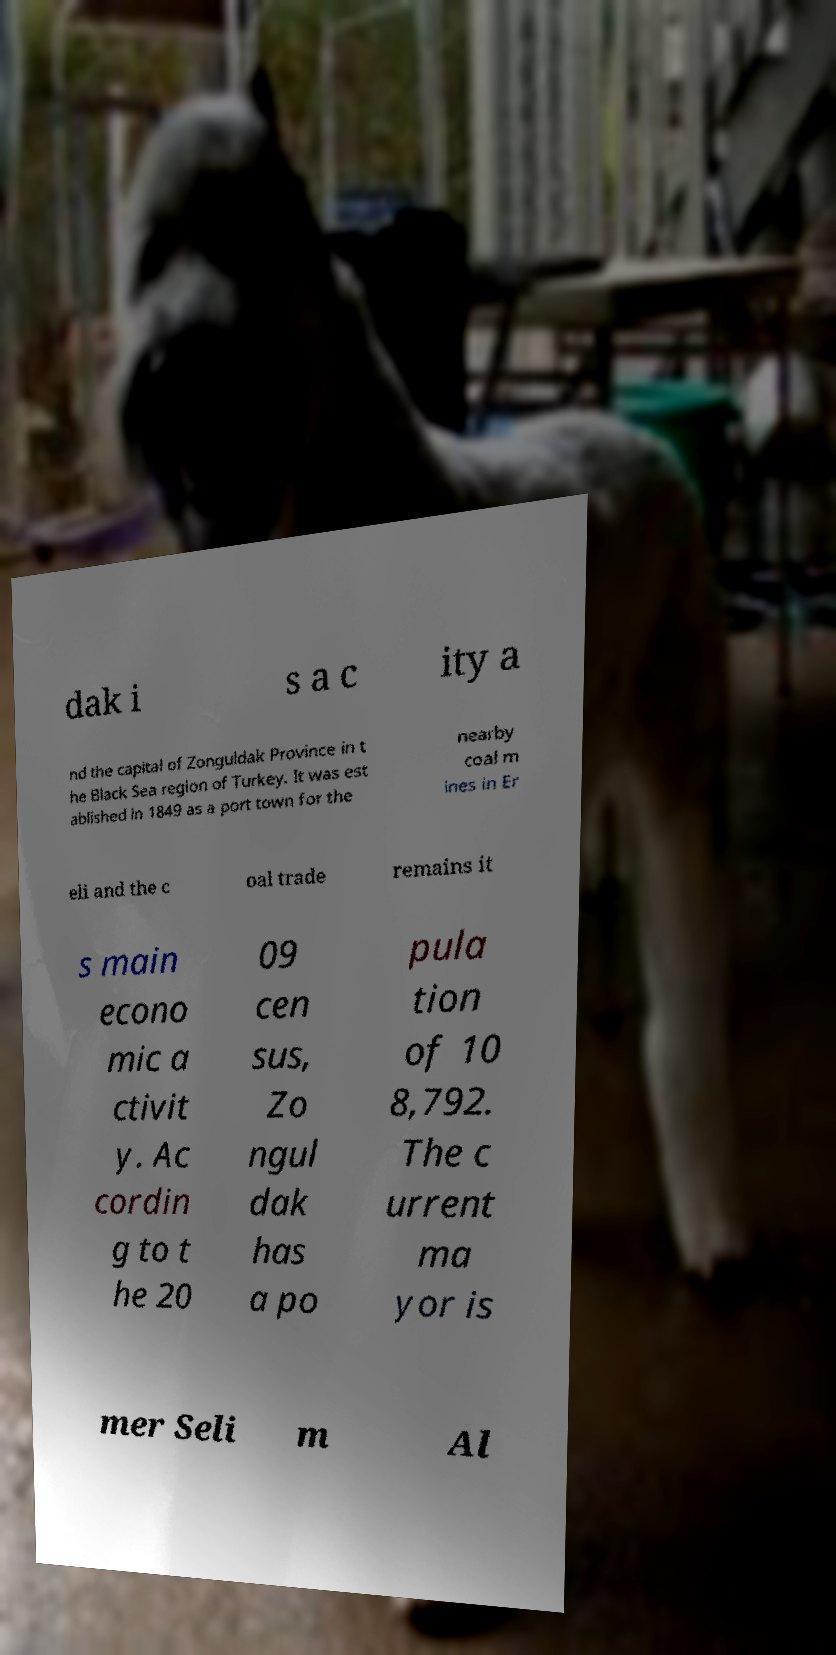There's text embedded in this image that I need extracted. Can you transcribe it verbatim? dak i s a c ity a nd the capital of Zonguldak Province in t he Black Sea region of Turkey. It was est ablished in 1849 as a port town for the nearby coal m ines in Er eli and the c oal trade remains it s main econo mic a ctivit y. Ac cordin g to t he 20 09 cen sus, Zo ngul dak has a po pula tion of 10 8,792. The c urrent ma yor is mer Seli m Al 